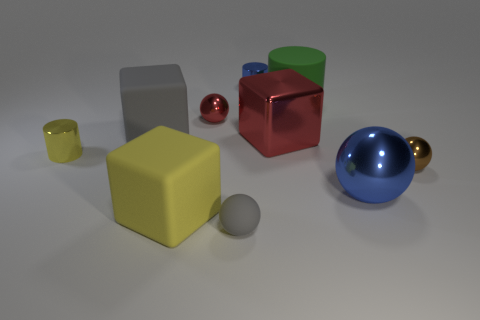Subtract all balls. How many objects are left? 6 Add 1 big blue objects. How many big blue objects exist? 2 Subtract 0 purple balls. How many objects are left? 10 Subtract all large yellow metallic balls. Subtract all tiny red metallic spheres. How many objects are left? 9 Add 9 brown spheres. How many brown spheres are left? 10 